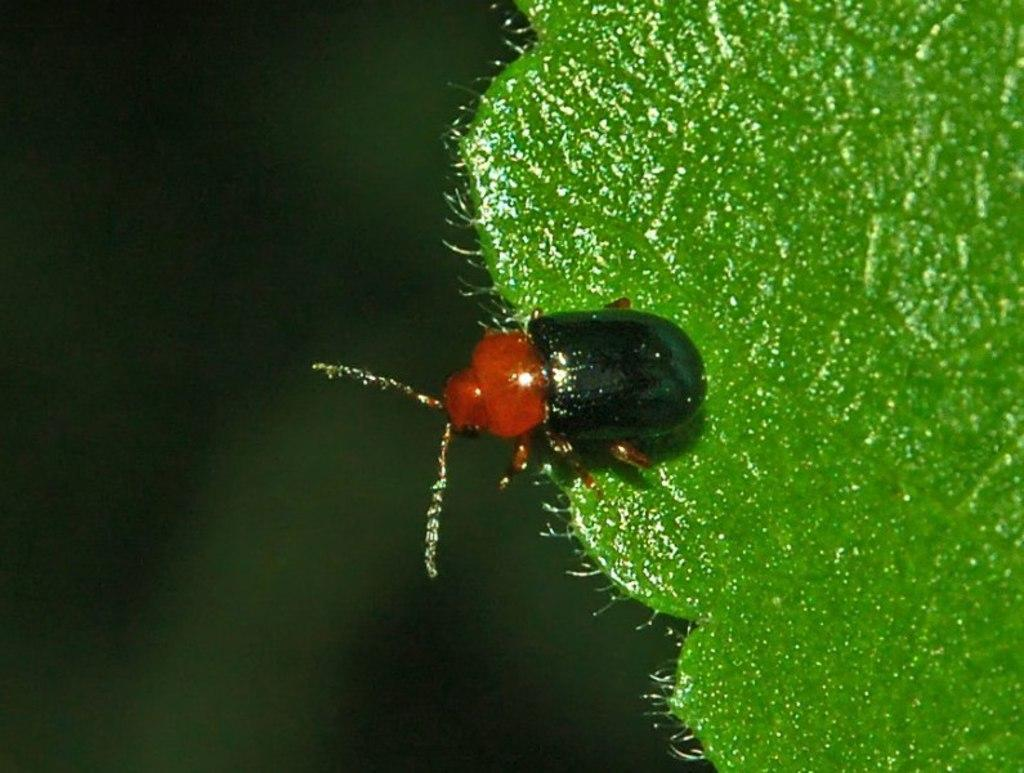What type of creature is present in the image? There is an insect in the image. Where is the insect located? The insect is on a green object, which appears to be a leaf of a plant. Can you describe the background of the image? The background of the image is blurry. What type of scarf is the insect wearing in the image? There is no scarf present in the image, and insects do not wear clothing. 